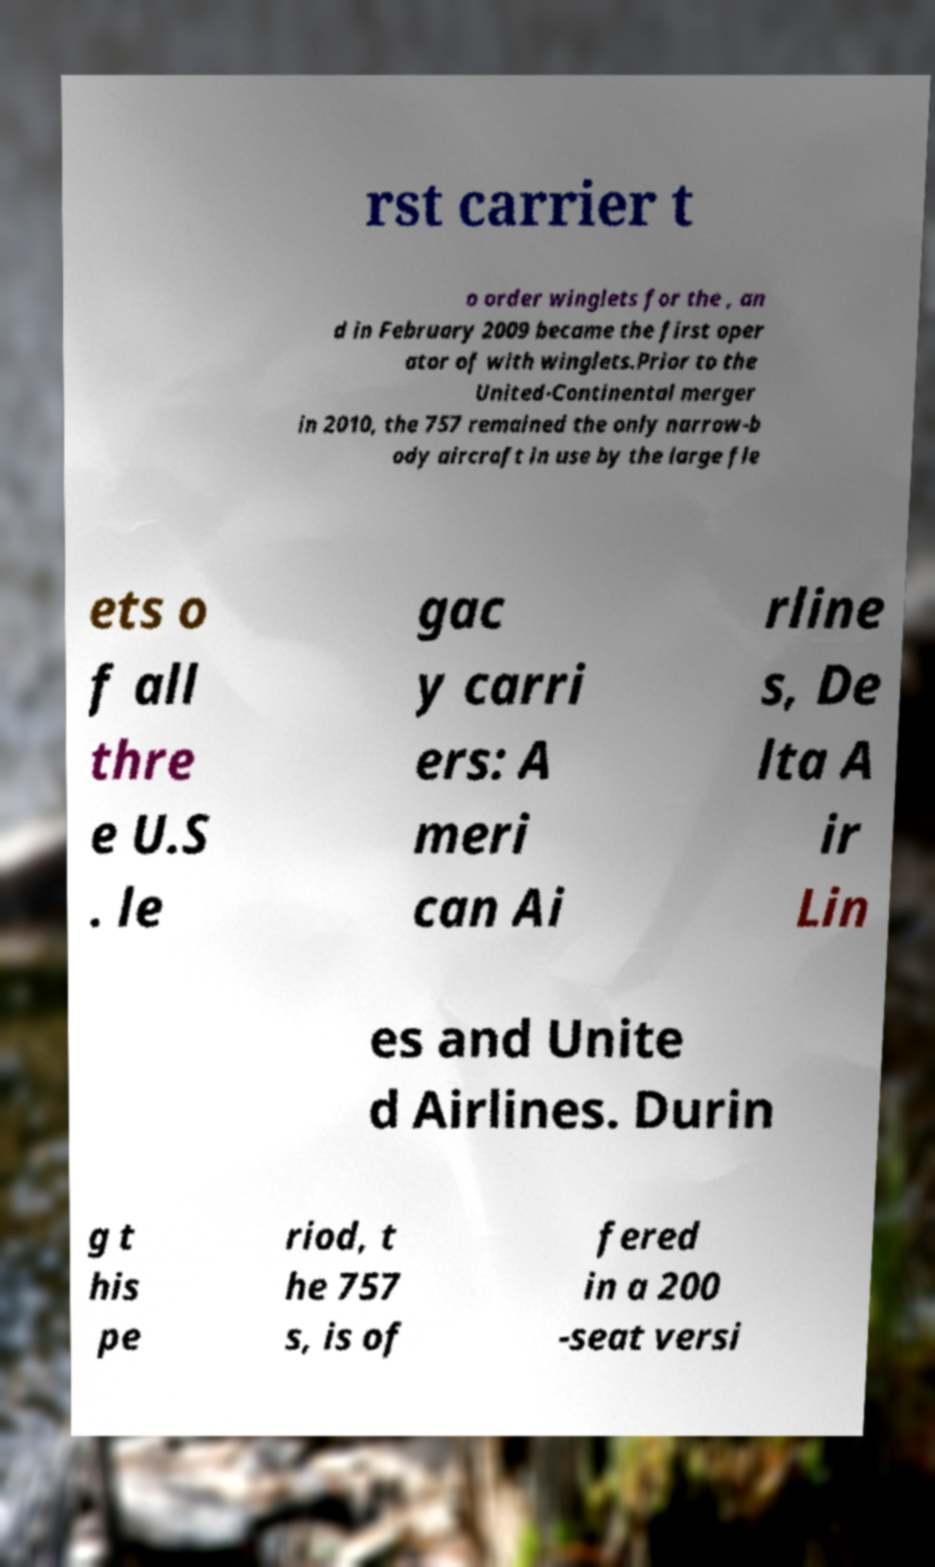Could you assist in decoding the text presented in this image and type it out clearly? rst carrier t o order winglets for the , an d in February 2009 became the first oper ator of with winglets.Prior to the United-Continental merger in 2010, the 757 remained the only narrow-b ody aircraft in use by the large fle ets o f all thre e U.S . le gac y carri ers: A meri can Ai rline s, De lta A ir Lin es and Unite d Airlines. Durin g t his pe riod, t he 757 s, is of fered in a 200 -seat versi 